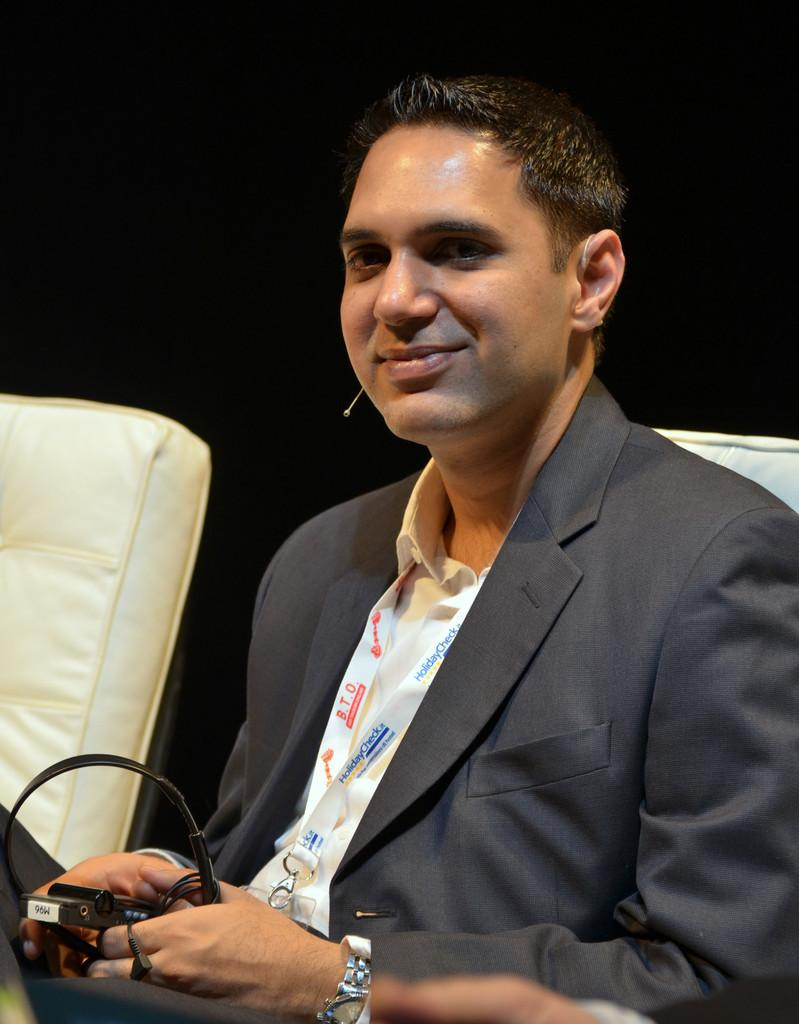Who is present in the image? There is a man in the image. What is the man wearing? The man is wearing a suit. What is the man doing in the image? The man is sitting on a chair and holding a device in his hands. What other furniture can be seen in the image? There is another couch in the left corner of the image. What type of wheel is visible on the sidewalk in the image? There is no sidewalk or wheel present in the image; it features a man sitting on a chair and holding a device in his hands. 